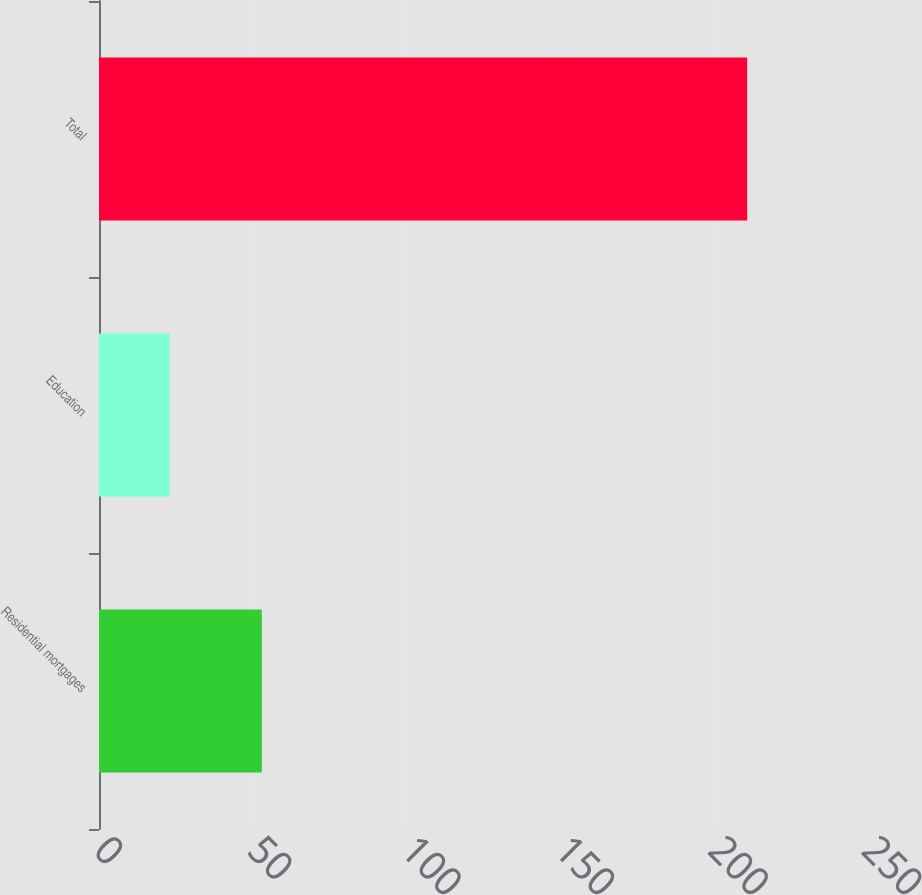<chart> <loc_0><loc_0><loc_500><loc_500><bar_chart><fcel>Residential mortgages<fcel>Education<fcel>Total<nl><fcel>53<fcel>23<fcel>211<nl></chart> 